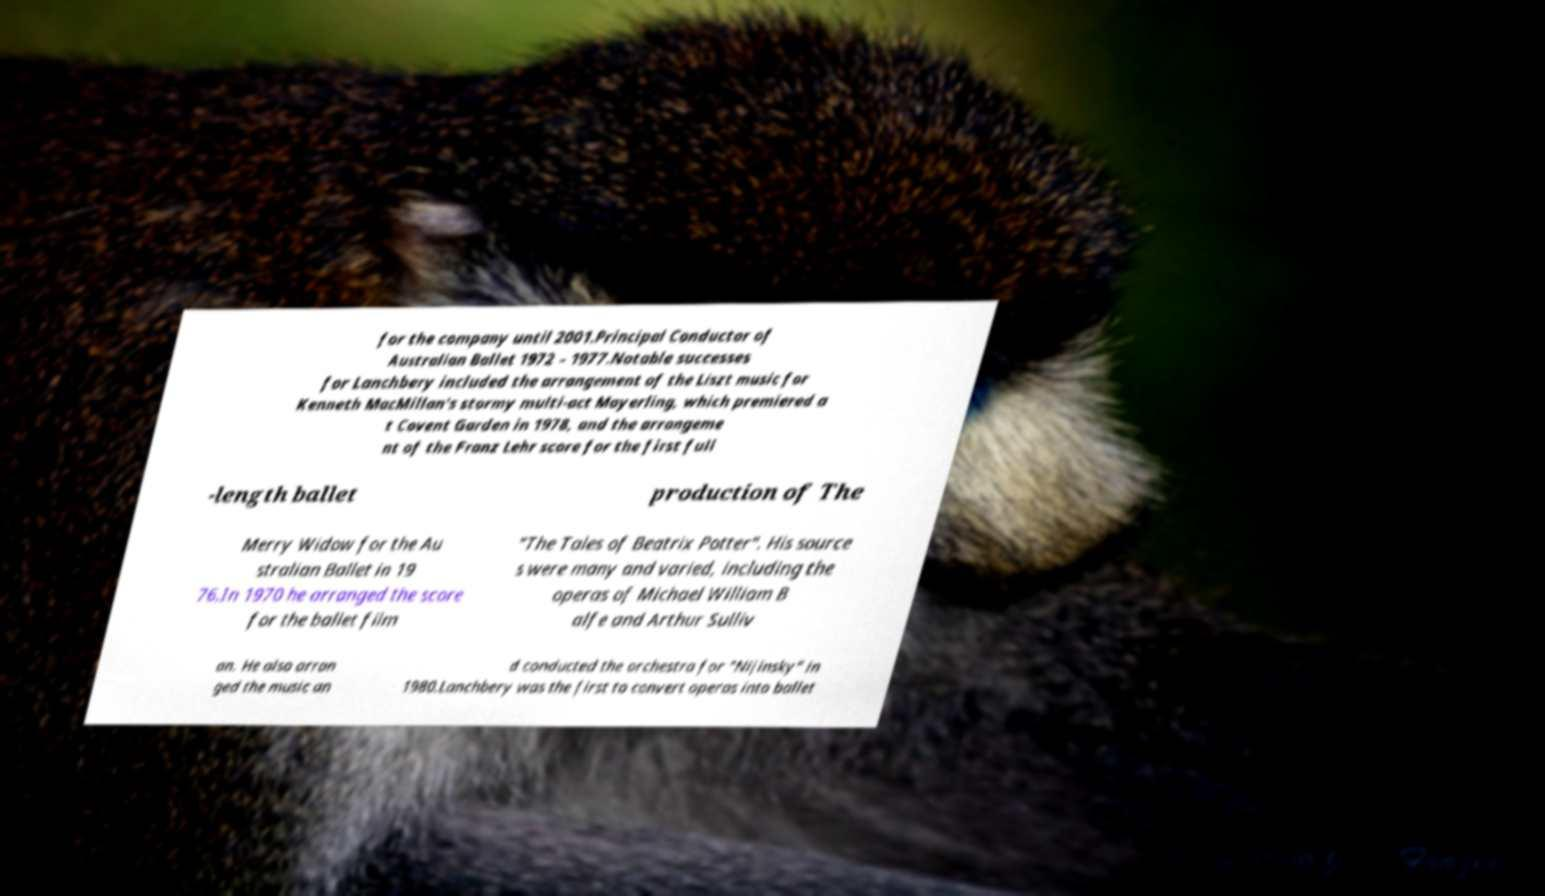I need the written content from this picture converted into text. Can you do that? for the company until 2001.Principal Conductor of Australian Ballet 1972 – 1977.Notable successes for Lanchbery included the arrangement of the Liszt music for Kenneth MacMillan's stormy multi-act Mayerling, which premiered a t Covent Garden in 1978, and the arrangeme nt of the Franz Lehr score for the first full -length ballet production of The Merry Widow for the Au stralian Ballet in 19 76.In 1970 he arranged the score for the ballet film "The Tales of Beatrix Potter". His source s were many and varied, including the operas of Michael William B alfe and Arthur Sulliv an. He also arran ged the music an d conducted the orchestra for "Nijinsky" in 1980.Lanchbery was the first to convert operas into ballet 